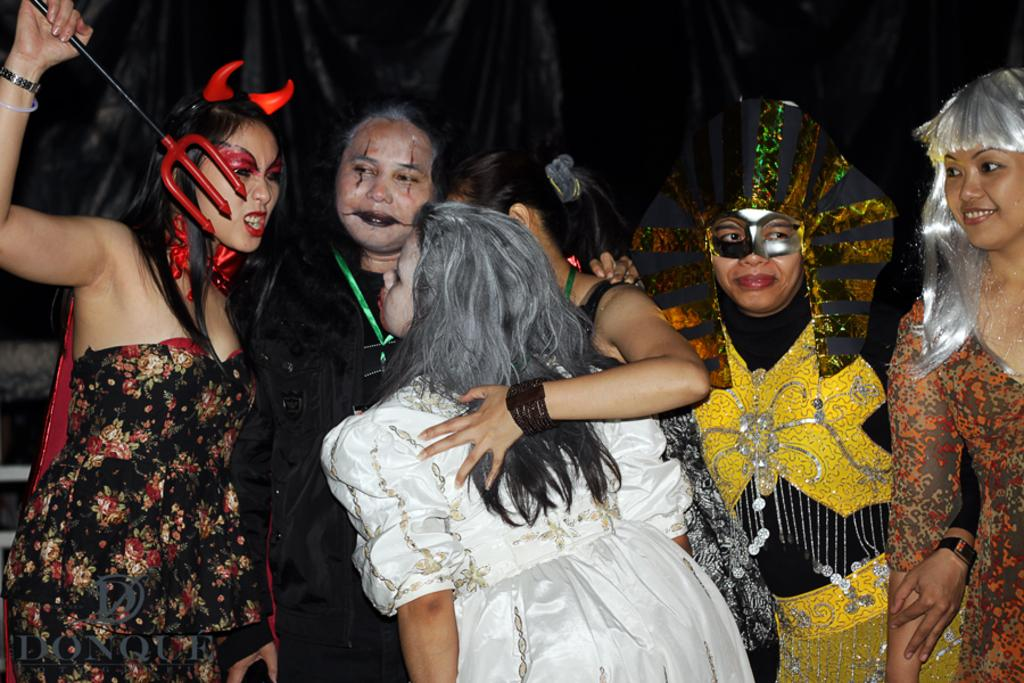What are the people in the image wearing? The people in the image are wearing Halloween costumes. Can you describe what one of the people is holding? One of the people is holding an object. What color is the object in the background of the image? There is a black color object in the background of the image. Can you tell me how many horses are present in the image? There are no horses present in the image. What type of thumb is visible in the image? There is no thumb visible in the image. 